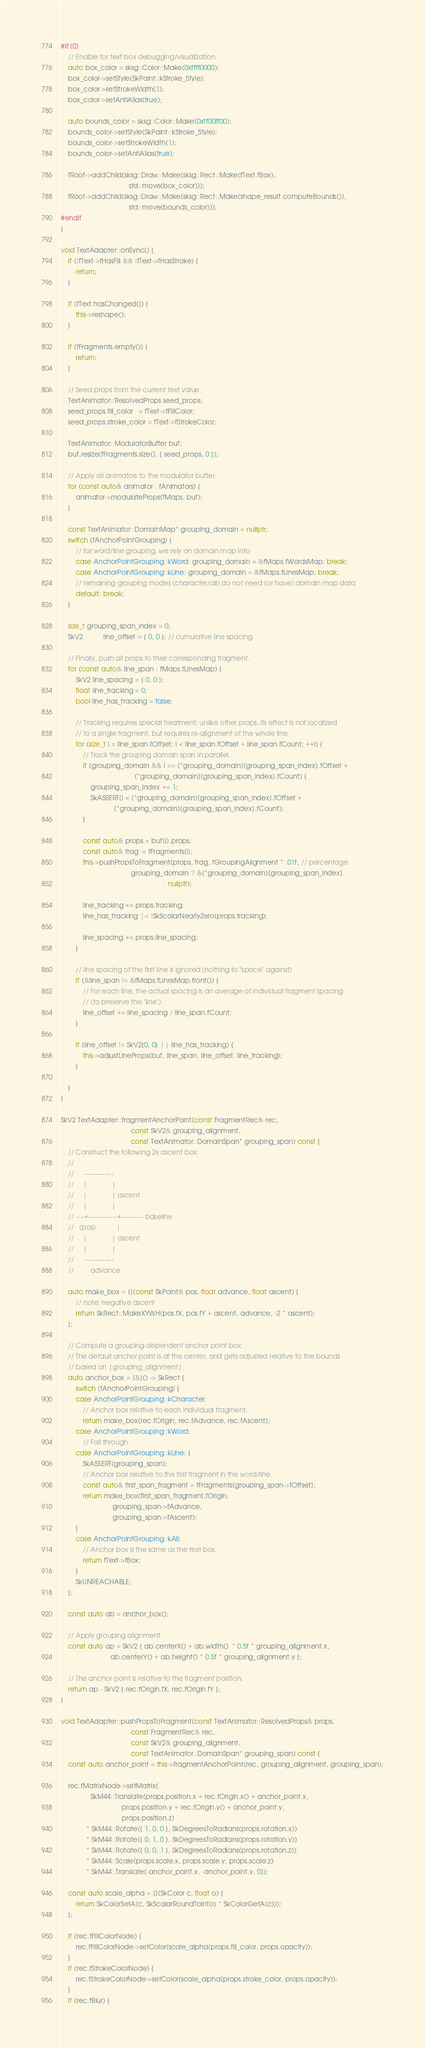Convert code to text. <code><loc_0><loc_0><loc_500><loc_500><_C++_>#if (0)
    // Enable for text box debugging/visualization.
    auto box_color = sksg::Color::Make(0xffff0000);
    box_color->setStyle(SkPaint::kStroke_Style);
    box_color->setStrokeWidth(1);
    box_color->setAntiAlias(true);

    auto bounds_color = sksg::Color::Make(0xff00ff00);
    bounds_color->setStyle(SkPaint::kStroke_Style);
    bounds_color->setStrokeWidth(1);
    bounds_color->setAntiAlias(true);

    fRoot->addChild(sksg::Draw::Make(sksg::Rect::Make(fText.fBox),
                                     std::move(box_color)));
    fRoot->addChild(sksg::Draw::Make(sksg::Rect::Make(shape_result.computeBounds()),
                                     std::move(bounds_color)));
#endif
}

void TextAdapter::onSync() {
    if (!fText->fHasFill && !fText->fHasStroke) {
        return;
    }

    if (fText.hasChanged()) {
        this->reshape();
    }

    if (fFragments.empty()) {
        return;
    }

    // Seed props from the current text value.
    TextAnimator::ResolvedProps seed_props;
    seed_props.fill_color   = fText->fFillColor;
    seed_props.stroke_color = fText->fStrokeColor;

    TextAnimator::ModulatorBuffer buf;
    buf.resize(fFragments.size(), { seed_props, 0 });

    // Apply all animators to the modulator buffer.
    for (const auto& animator : fAnimators) {
        animator->modulateProps(fMaps, buf);
    }

    const TextAnimator::DomainMap* grouping_domain = nullptr;
    switch (fAnchorPointGrouping) {
        // for word/line grouping, we rely on domain map info
        case AnchorPointGrouping::kWord: grouping_domain = &fMaps.fWordsMap; break;
        case AnchorPointGrouping::kLine: grouping_domain = &fMaps.fLinesMap; break;
        // remaining grouping modes (character/all) do not need (or have) domain map data
        default: break;
    }

    size_t grouping_span_index = 0;
    SkV2           line_offset = { 0, 0 }; // cumulative line spacing

    // Finally, push all props to their corresponding fragment.
    for (const auto& line_span : fMaps.fLinesMap) {
        SkV2 line_spacing = { 0, 0 };
        float line_tracking = 0;
        bool line_has_tracking = false;

        // Tracking requires special treatment: unlike other props, its effect is not localized
        // to a single fragment, but requires re-alignment of the whole line.
        for (size_t i = line_span.fOffset; i < line_span.fOffset + line_span.fCount; ++i) {
            // Track the grouping domain span in parallel.
            if (grouping_domain && i >= (*grouping_domain)[grouping_span_index].fOffset +
                                        (*grouping_domain)[grouping_span_index].fCount) {
                grouping_span_index += 1;
                SkASSERT(i < (*grouping_domain)[grouping_span_index].fOffset +
                             (*grouping_domain)[grouping_span_index].fCount);
            }

            const auto& props = buf[i].props;
            const auto& frag  = fFragments[i];
            this->pushPropsToFragment(props, frag, fGroupingAlignment * .01f, // percentage
                                      grouping_domain ? &(*grouping_domain)[grouping_span_index]
                                                        : nullptr);

            line_tracking += props.tracking;
            line_has_tracking |= !SkScalarNearlyZero(props.tracking);

            line_spacing += props.line_spacing;
        }

        // line spacing of the first line is ignored (nothing to "space" against)
        if (&line_span != &fMaps.fLinesMap.front()) {
            // For each line, the actual spacing is an average of individual fragment spacing
            // (to preserve the "line").
            line_offset += line_spacing / line_span.fCount;
        }

        if (line_offset != SkV2{0, 0} || line_has_tracking) {
            this->adjustLineProps(buf, line_span, line_offset, line_tracking);
        }

    }
}

SkV2 TextAdapter::fragmentAnchorPoint(const FragmentRec& rec,
                                      const SkV2& grouping_alignment,
                                      const TextAnimator::DomainSpan* grouping_span) const {
    // Construct the following 2x ascent box:
    //
    //      -------------
    //     |             |
    //     |             | ascent
    //     |             |
    // ----+-------------+---------- baseline
    //   (pos)           |
    //     |             | ascent
    //     |             |
    //      -------------
    //         advance

    auto make_box = [](const SkPoint& pos, float advance, float ascent) {
        // note: negative ascent
        return SkRect::MakeXYWH(pos.fX, pos.fY + ascent, advance, -2 * ascent);
    };

    // Compute a grouping-dependent anchor point box.
    // The default anchor point is at the center, and gets adjusted relative to the bounds
    // based on |grouping_alignment|.
    auto anchor_box = [&]() -> SkRect {
        switch (fAnchorPointGrouping) {
        case AnchorPointGrouping::kCharacter:
            // Anchor box relative to each individual fragment.
            return make_box(rec.fOrigin, rec.fAdvance, rec.fAscent);
        case AnchorPointGrouping::kWord:
            // Fall through
        case AnchorPointGrouping::kLine: {
            SkASSERT(grouping_span);
            // Anchor box relative to the first fragment in the word/line.
            const auto& first_span_fragment = fFragments[grouping_span->fOffset];
            return make_box(first_span_fragment.fOrigin,
                            grouping_span->fAdvance,
                            grouping_span->fAscent);
        }
        case AnchorPointGrouping::kAll:
            // Anchor box is the same as the text box.
            return fText->fBox;
        }
        SkUNREACHABLE;
    };

    const auto ab = anchor_box();

    // Apply grouping alignment.
    const auto ap = SkV2 { ab.centerX() + ab.width()  * 0.5f * grouping_alignment.x,
                           ab.centerY() + ab.height() * 0.5f * grouping_alignment.y };

    // The anchor point is relative to the fragment position.
    return ap - SkV2 { rec.fOrigin.fX, rec.fOrigin.fY };
}

void TextAdapter::pushPropsToFragment(const TextAnimator::ResolvedProps& props,
                                      const FragmentRec& rec,
                                      const SkV2& grouping_alignment,
                                      const TextAnimator::DomainSpan* grouping_span) const {
    const auto anchor_point = this->fragmentAnchorPoint(rec, grouping_alignment, grouping_span);

    rec.fMatrixNode->setMatrix(
                SkM44::Translate(props.position.x + rec.fOrigin.x() + anchor_point.x,
                                 props.position.y + rec.fOrigin.y() + anchor_point.y,
                                 props.position.z)
              * SkM44::Rotate({ 1, 0, 0 }, SkDegreesToRadians(props.rotation.x))
              * SkM44::Rotate({ 0, 1, 0 }, SkDegreesToRadians(props.rotation.y))
              * SkM44::Rotate({ 0, 0, 1 }, SkDegreesToRadians(props.rotation.z))
              * SkM44::Scale(props.scale.x, props.scale.y, props.scale.z)
              * SkM44::Translate(-anchor_point.x, -anchor_point.y, 0));

    const auto scale_alpha = [](SkColor c, float o) {
        return SkColorSetA(c, SkScalarRoundToInt(o * SkColorGetA(c)));
    };

    if (rec.fFillColorNode) {
        rec.fFillColorNode->setColor(scale_alpha(props.fill_color, props.opacity));
    }
    if (rec.fStrokeColorNode) {
        rec.fStrokeColorNode->setColor(scale_alpha(props.stroke_color, props.opacity));
    }
    if (rec.fBlur) {</code> 